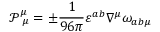<formula> <loc_0><loc_0><loc_500><loc_500>\mathcal { P } _ { \ \mu } ^ { \mu } = \pm \frac { 1 } { 9 6 \pi } \varepsilon ^ { a b } \nabla ^ { \mu } \omega _ { a b \mu }</formula> 